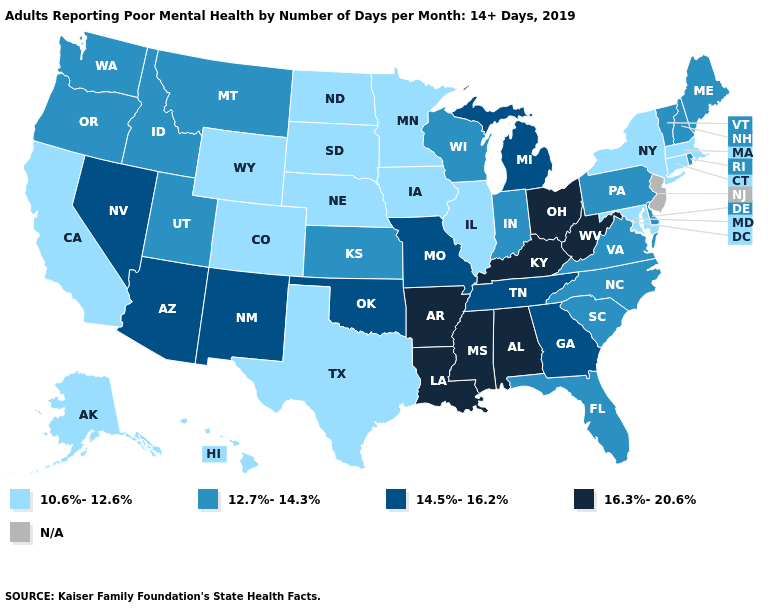What is the highest value in the MidWest ?
Short answer required. 16.3%-20.6%. What is the value of Florida?
Quick response, please. 12.7%-14.3%. Among the states that border Michigan , does Ohio have the lowest value?
Quick response, please. No. Does New York have the lowest value in the USA?
Write a very short answer. Yes. Does Ohio have the lowest value in the USA?
Give a very brief answer. No. Among the states that border New York , which have the highest value?
Answer briefly. Pennsylvania, Vermont. What is the highest value in states that border Louisiana?
Short answer required. 16.3%-20.6%. What is the lowest value in states that border Oklahoma?
Concise answer only. 10.6%-12.6%. What is the highest value in the USA?
Give a very brief answer. 16.3%-20.6%. What is the highest value in the MidWest ?
Short answer required. 16.3%-20.6%. Which states have the lowest value in the USA?
Quick response, please. Alaska, California, Colorado, Connecticut, Hawaii, Illinois, Iowa, Maryland, Massachusetts, Minnesota, Nebraska, New York, North Dakota, South Dakota, Texas, Wyoming. What is the highest value in the USA?
Concise answer only. 16.3%-20.6%. Among the states that border Oregon , which have the lowest value?
Give a very brief answer. California. Name the states that have a value in the range 12.7%-14.3%?
Quick response, please. Delaware, Florida, Idaho, Indiana, Kansas, Maine, Montana, New Hampshire, North Carolina, Oregon, Pennsylvania, Rhode Island, South Carolina, Utah, Vermont, Virginia, Washington, Wisconsin. Name the states that have a value in the range 14.5%-16.2%?
Short answer required. Arizona, Georgia, Michigan, Missouri, Nevada, New Mexico, Oklahoma, Tennessee. 